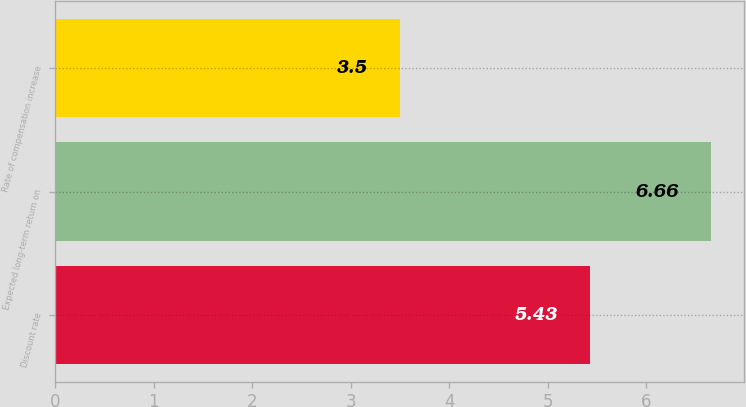<chart> <loc_0><loc_0><loc_500><loc_500><bar_chart><fcel>Discount rate<fcel>Expected long-term return on<fcel>Rate of compensation increase<nl><fcel>5.43<fcel>6.66<fcel>3.5<nl></chart> 